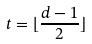<formula> <loc_0><loc_0><loc_500><loc_500>t = \lfloor \frac { d - 1 } { 2 } \rfloor</formula> 